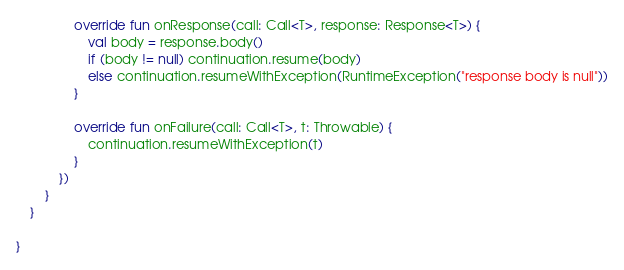Convert code to text. <code><loc_0><loc_0><loc_500><loc_500><_Kotlin_>                override fun onResponse(call: Call<T>, response: Response<T>) {
                    val body = response.body()
                    if (body != null) continuation.resume(body)
                    else continuation.resumeWithException(RuntimeException("response body is null"))
                }

                override fun onFailure(call: Call<T>, t: Throwable) {
                    continuation.resumeWithException(t)
                }
            })
        }
    }

}</code> 